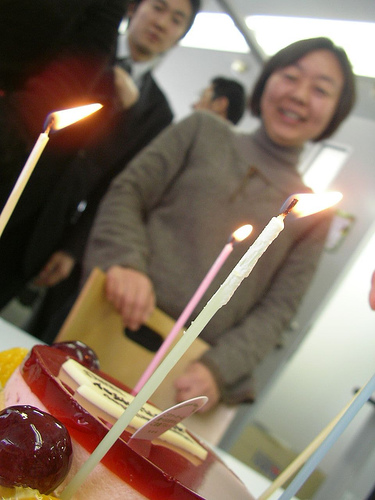What emotions seem to be depicted by the person in the image? The person in the image exudes happiness and appears to be genuinely smiling, hinting at a sense of joy and contentment during this festive moment. 